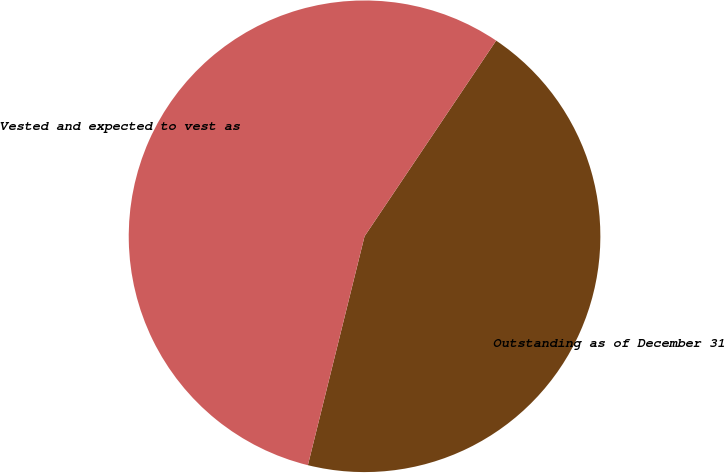<chart> <loc_0><loc_0><loc_500><loc_500><pie_chart><fcel>Outstanding as of December 31<fcel>Vested and expected to vest as<nl><fcel>44.44%<fcel>55.56%<nl></chart> 